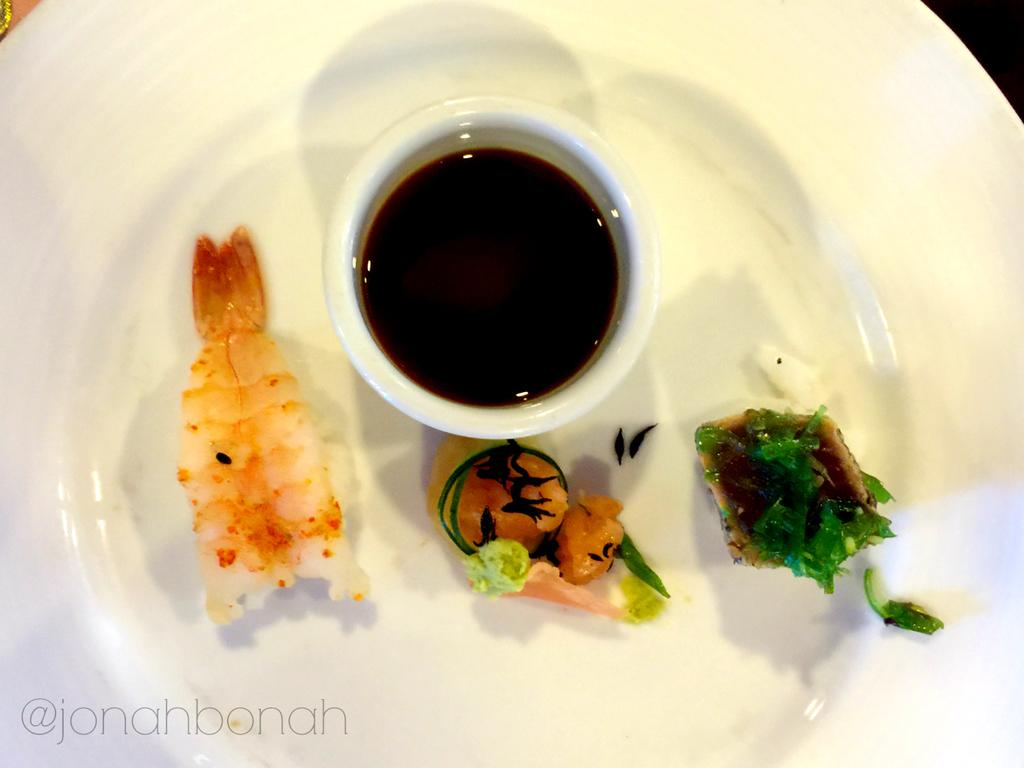What is on the plate in the image? There is food in the plate in the image. What accompanies the food on the plate? There is a bowl with sauce in the image. Is there any text or logo visible in the image? Yes, there is a watermark in the bottom left corner of the image. Can you hear the salt being poured in the image? There is no sound in the image, and salt is not being poured. The image is a still representation and does not convey any auditory information. 